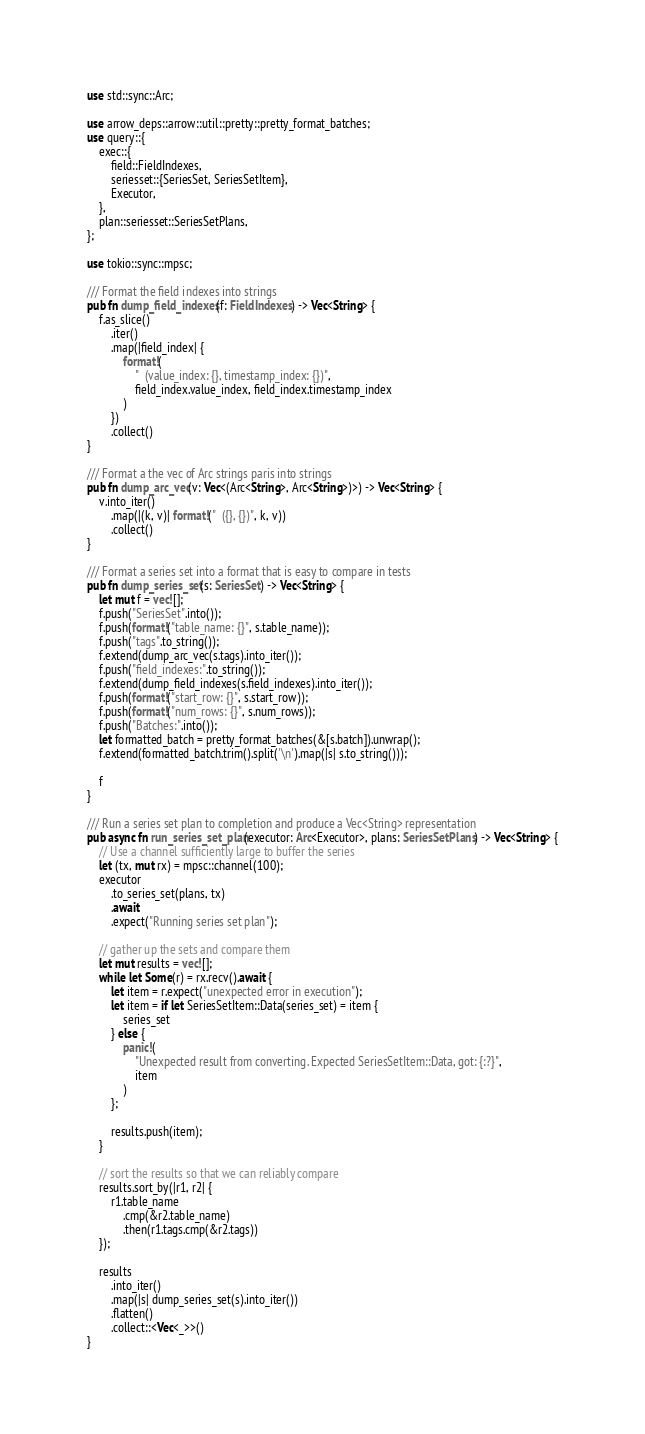Convert code to text. <code><loc_0><loc_0><loc_500><loc_500><_Rust_>use std::sync::Arc;

use arrow_deps::arrow::util::pretty::pretty_format_batches;
use query::{
    exec::{
        field::FieldIndexes,
        seriesset::{SeriesSet, SeriesSetItem},
        Executor,
    },
    plan::seriesset::SeriesSetPlans,
};

use tokio::sync::mpsc;

/// Format the field indexes into strings
pub fn dump_field_indexes(f: FieldIndexes) -> Vec<String> {
    f.as_slice()
        .iter()
        .map(|field_index| {
            format!(
                "  (value_index: {}, timestamp_index: {})",
                field_index.value_index, field_index.timestamp_index
            )
        })
        .collect()
}

/// Format a the vec of Arc strings paris into strings
pub fn dump_arc_vec(v: Vec<(Arc<String>, Arc<String>)>) -> Vec<String> {
    v.into_iter()
        .map(|(k, v)| format!("  ({}, {})", k, v))
        .collect()
}

/// Format a series set into a format that is easy to compare in tests
pub fn dump_series_set(s: SeriesSet) -> Vec<String> {
    let mut f = vec![];
    f.push("SeriesSet".into());
    f.push(format!("table_name: {}", s.table_name));
    f.push("tags".to_string());
    f.extend(dump_arc_vec(s.tags).into_iter());
    f.push("field_indexes:".to_string());
    f.extend(dump_field_indexes(s.field_indexes).into_iter());
    f.push(format!("start_row: {}", s.start_row));
    f.push(format!("num_rows: {}", s.num_rows));
    f.push("Batches:".into());
    let formatted_batch = pretty_format_batches(&[s.batch]).unwrap();
    f.extend(formatted_batch.trim().split('\n').map(|s| s.to_string()));

    f
}

/// Run a series set plan to completion and produce a Vec<String> representation
pub async fn run_series_set_plan(executor: Arc<Executor>, plans: SeriesSetPlans) -> Vec<String> {
    // Use a channel sufficiently large to buffer the series
    let (tx, mut rx) = mpsc::channel(100);
    executor
        .to_series_set(plans, tx)
        .await
        .expect("Running series set plan");

    // gather up the sets and compare them
    let mut results = vec![];
    while let Some(r) = rx.recv().await {
        let item = r.expect("unexpected error in execution");
        let item = if let SeriesSetItem::Data(series_set) = item {
            series_set
        } else {
            panic!(
                "Unexpected result from converting. Expected SeriesSetItem::Data, got: {:?}",
                item
            )
        };

        results.push(item);
    }

    // sort the results so that we can reliably compare
    results.sort_by(|r1, r2| {
        r1.table_name
            .cmp(&r2.table_name)
            .then(r1.tags.cmp(&r2.tags))
    });

    results
        .into_iter()
        .map(|s| dump_series_set(s).into_iter())
        .flatten()
        .collect::<Vec<_>>()
}
</code> 